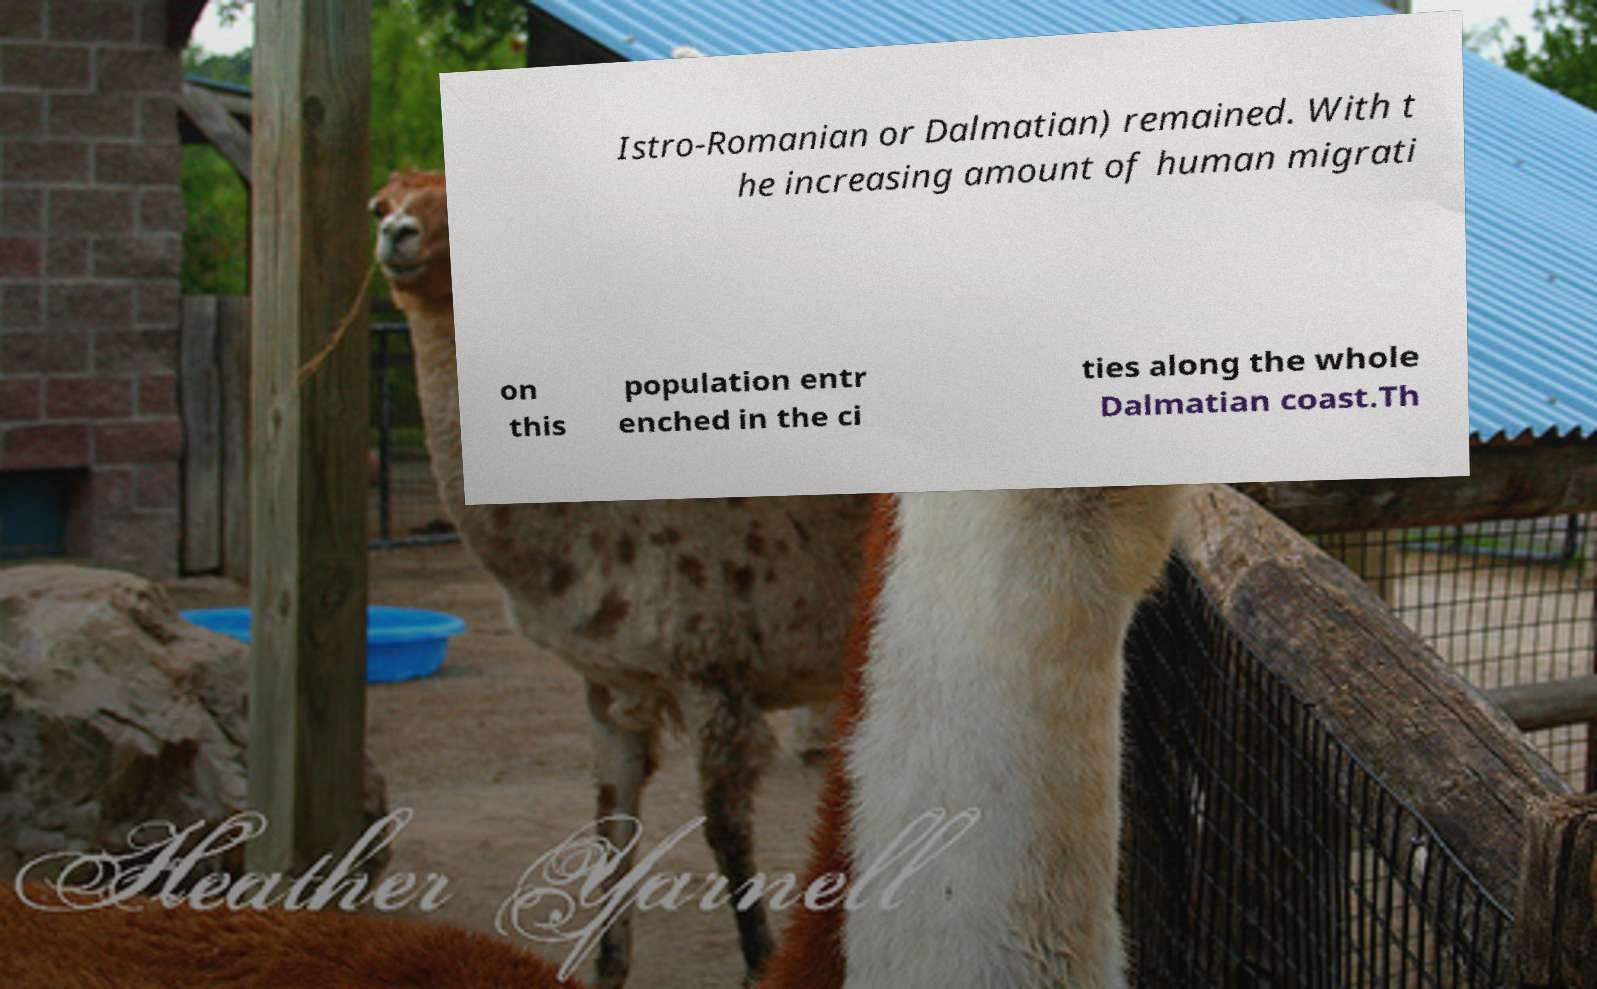There's text embedded in this image that I need extracted. Can you transcribe it verbatim? Istro-Romanian or Dalmatian) remained. With t he increasing amount of human migrati on this population entr enched in the ci ties along the whole Dalmatian coast.Th 